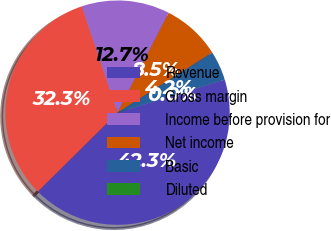Convert chart. <chart><loc_0><loc_0><loc_500><loc_500><pie_chart><fcel>Revenue<fcel>Gross margin<fcel>Income before provision for<fcel>Net income<fcel>Basic<fcel>Diluted<nl><fcel>42.34%<fcel>32.25%<fcel>12.7%<fcel>8.47%<fcel>4.23%<fcel>0.0%<nl></chart> 